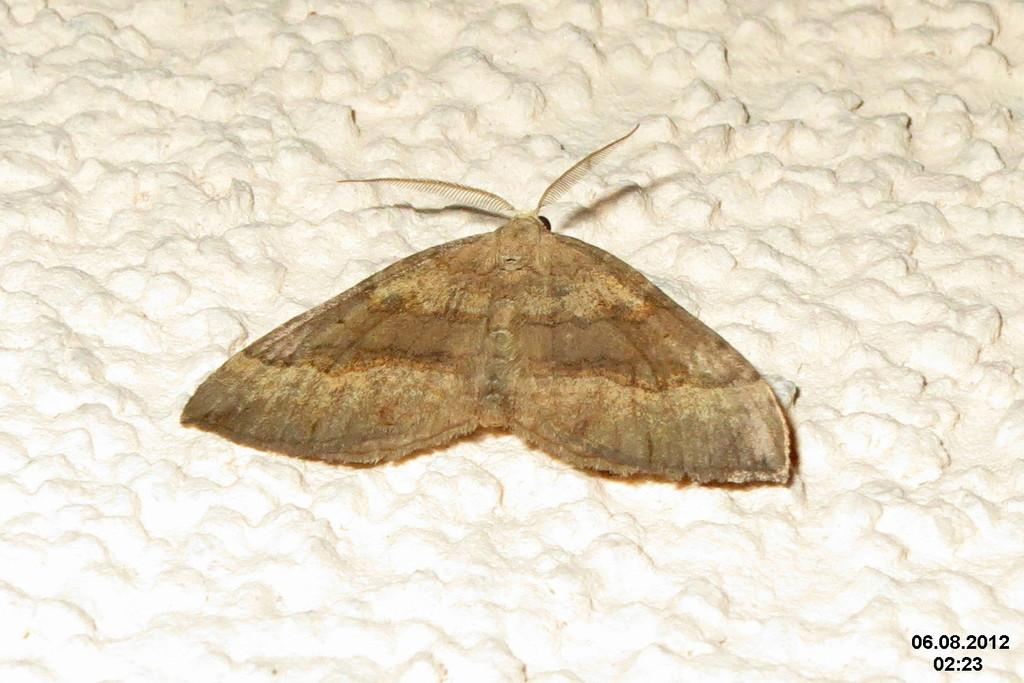What is the main subject of the image? There is a butterfly in the image. Where is the butterfly located? The butterfly is on a wall. What is the color of the wall? The wall is white in color. Is there any additional information about the image? Yes, there is a watermark in the bottom right side of the image. How many toys are visible in the image? There are no toys present in the image; it features a butterfly on a white wall. Can you see any cats in the image? There are no cats visible in the image. 